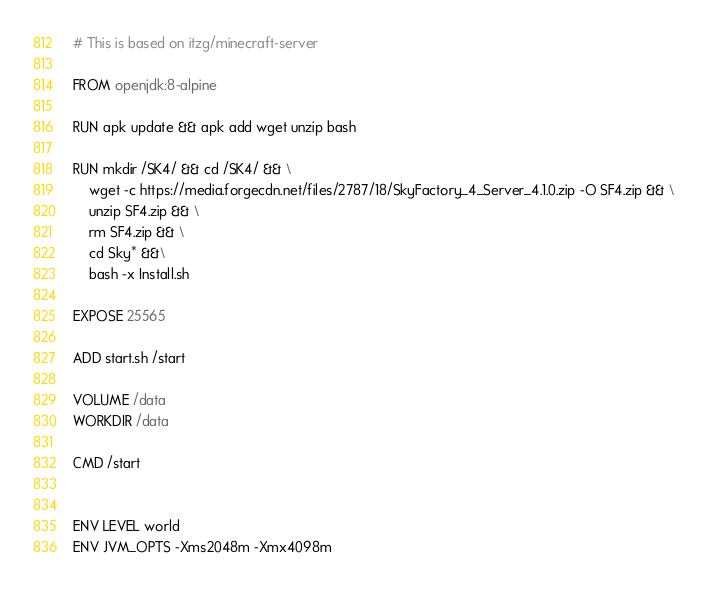<code> <loc_0><loc_0><loc_500><loc_500><_Dockerfile_># This is based on itzg/minecraft-server

FROM openjdk:8-alpine

RUN apk update && apk add wget unzip bash

RUN mkdir /SK4/ && cd /SK4/ && \
	wget -c https://media.forgecdn.net/files/2787/18/SkyFactory_4_Server_4.1.0.zip -O SF4.zip && \
	unzip SF4.zip && \
	rm SF4.zip && \
	cd Sky* &&\
	bash -x Install.sh

EXPOSE 25565

ADD start.sh /start

VOLUME /data
WORKDIR /data

CMD /start


ENV LEVEL world
ENV JVM_OPTS -Xms2048m -Xmx4098m
</code> 